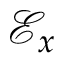<formula> <loc_0><loc_0><loc_500><loc_500>\mathcal { E } _ { x }</formula> 